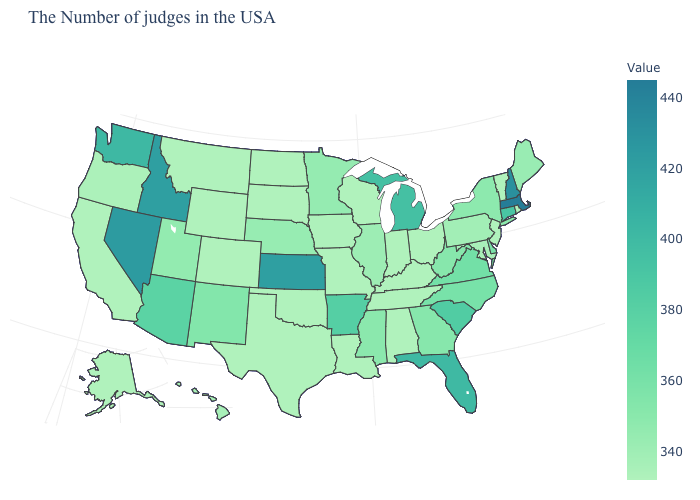Which states have the highest value in the USA?
Keep it brief. Massachusetts. Which states have the highest value in the USA?
Give a very brief answer. Massachusetts. Does Florida have the lowest value in the South?
Quick response, please. No. Among the states that border Washington , does Idaho have the highest value?
Concise answer only. Yes. Which states have the highest value in the USA?
Keep it brief. Massachusetts. Does Michigan have the lowest value in the MidWest?
Quick response, please. No. 